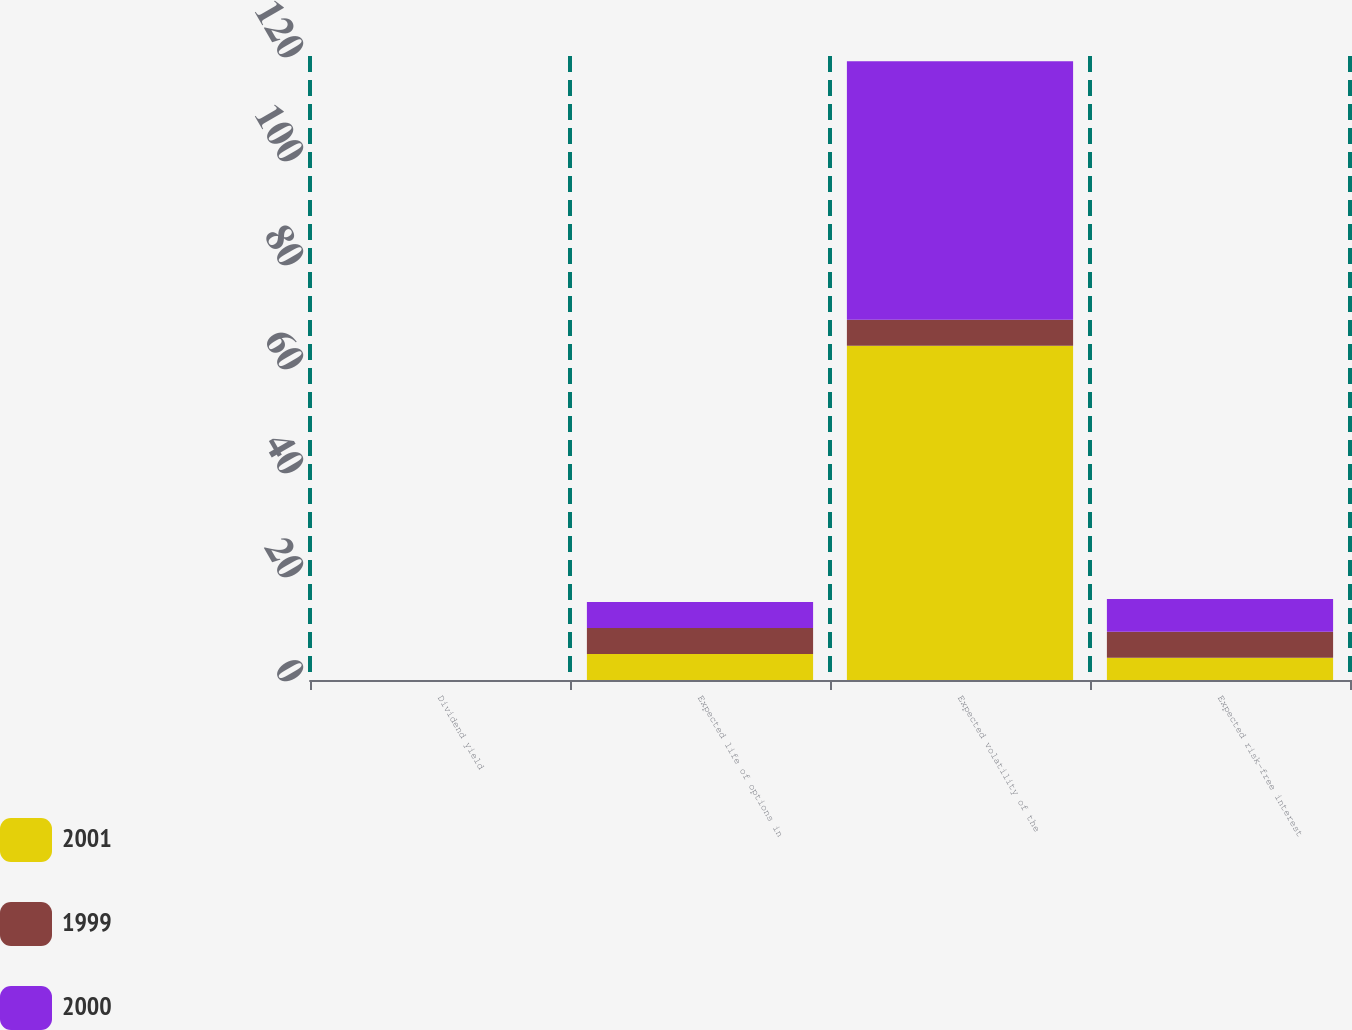Convert chart. <chart><loc_0><loc_0><loc_500><loc_500><stacked_bar_chart><ecel><fcel>Dividend yield<fcel>Expected life of options in<fcel>Expected volatility of the<fcel>Expected risk-free interest<nl><fcel>2001<fcel>0<fcel>5<fcel>64.3<fcel>4.3<nl><fcel>1999<fcel>0<fcel>5<fcel>5<fcel>5<nl><fcel>2000<fcel>0<fcel>5<fcel>49.7<fcel>6.3<nl></chart> 